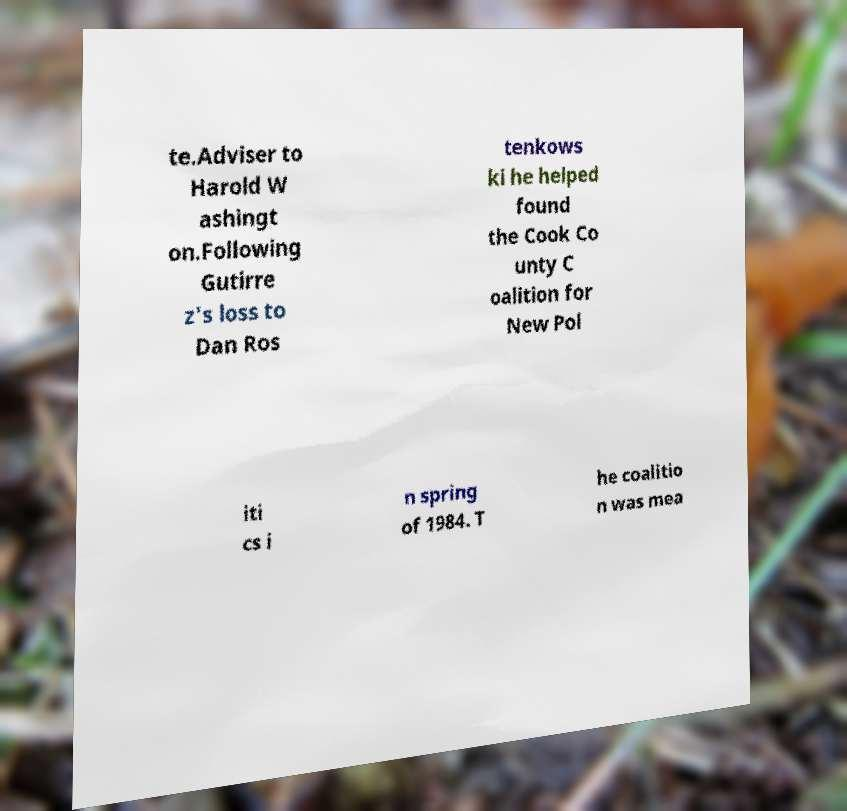What messages or text are displayed in this image? I need them in a readable, typed format. te.Adviser to Harold W ashingt on.Following Gutirre z's loss to Dan Ros tenkows ki he helped found the Cook Co unty C oalition for New Pol iti cs i n spring of 1984. T he coalitio n was mea 